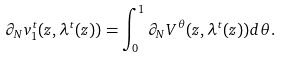Convert formula to latex. <formula><loc_0><loc_0><loc_500><loc_500>\partial _ { N } v ^ { t } _ { 1 } ( z , \lambda ^ { t } ( z ) ) = \int _ { 0 } ^ { 1 } \partial _ { N } V ^ { \theta } ( z , \lambda ^ { t } ( z ) ) d \theta .</formula> 